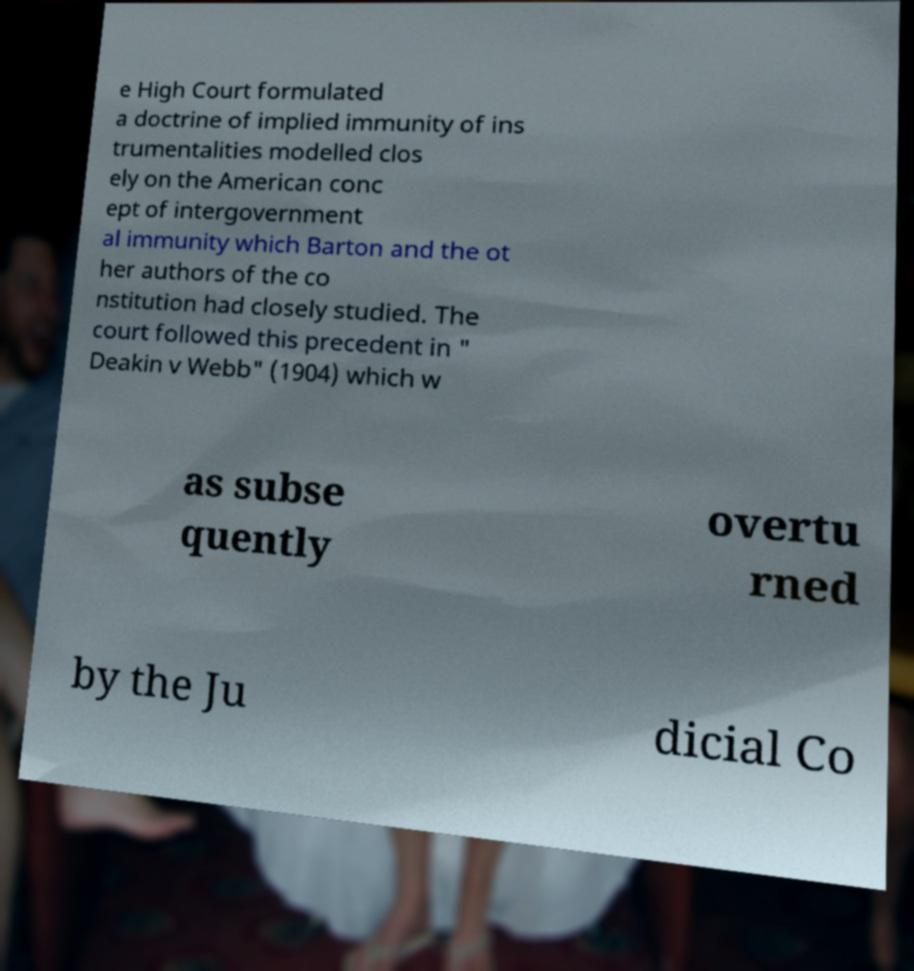There's text embedded in this image that I need extracted. Can you transcribe it verbatim? e High Court formulated a doctrine of implied immunity of ins trumentalities modelled clos ely on the American conc ept of intergovernment al immunity which Barton and the ot her authors of the co nstitution had closely studied. The court followed this precedent in " Deakin v Webb" (1904) which w as subse quently overtu rned by the Ju dicial Co 